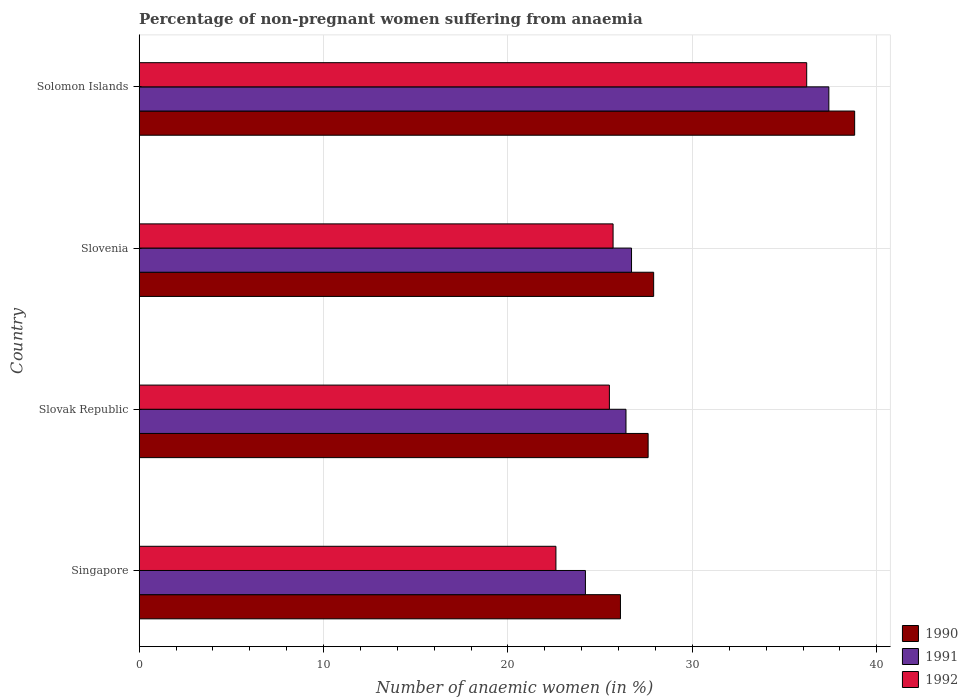How many different coloured bars are there?
Provide a succinct answer. 3. How many groups of bars are there?
Provide a succinct answer. 4. How many bars are there on the 2nd tick from the bottom?
Your answer should be compact. 3. What is the label of the 1st group of bars from the top?
Your answer should be compact. Solomon Islands. What is the percentage of non-pregnant women suffering from anaemia in 1991 in Singapore?
Ensure brevity in your answer.  24.2. Across all countries, what is the maximum percentage of non-pregnant women suffering from anaemia in 1992?
Provide a succinct answer. 36.2. Across all countries, what is the minimum percentage of non-pregnant women suffering from anaemia in 1991?
Your answer should be very brief. 24.2. In which country was the percentage of non-pregnant women suffering from anaemia in 1992 maximum?
Provide a succinct answer. Solomon Islands. In which country was the percentage of non-pregnant women suffering from anaemia in 1992 minimum?
Make the answer very short. Singapore. What is the total percentage of non-pregnant women suffering from anaemia in 1992 in the graph?
Keep it short and to the point. 110. What is the difference between the percentage of non-pregnant women suffering from anaemia in 1990 in Slovenia and that in Solomon Islands?
Give a very brief answer. -10.9. What is the difference between the percentage of non-pregnant women suffering from anaemia in 1990 in Solomon Islands and the percentage of non-pregnant women suffering from anaemia in 1992 in Slovenia?
Keep it short and to the point. 13.1. What is the average percentage of non-pregnant women suffering from anaemia in 1990 per country?
Give a very brief answer. 30.1. What is the difference between the percentage of non-pregnant women suffering from anaemia in 1992 and percentage of non-pregnant women suffering from anaemia in 1991 in Solomon Islands?
Make the answer very short. -1.2. In how many countries, is the percentage of non-pregnant women suffering from anaemia in 1990 greater than 28 %?
Your answer should be compact. 1. What is the ratio of the percentage of non-pregnant women suffering from anaemia in 1990 in Slovak Republic to that in Slovenia?
Provide a succinct answer. 0.99. What is the difference between the highest and the second highest percentage of non-pregnant women suffering from anaemia in 1990?
Make the answer very short. 10.9. What is the difference between the highest and the lowest percentage of non-pregnant women suffering from anaemia in 1991?
Provide a short and direct response. 13.2. Is the sum of the percentage of non-pregnant women suffering from anaemia in 1991 in Singapore and Slovenia greater than the maximum percentage of non-pregnant women suffering from anaemia in 1992 across all countries?
Offer a very short reply. Yes. What does the 1st bar from the bottom in Singapore represents?
Your answer should be very brief. 1990. How many bars are there?
Give a very brief answer. 12. Are all the bars in the graph horizontal?
Your response must be concise. Yes. How many countries are there in the graph?
Your response must be concise. 4. What is the title of the graph?
Ensure brevity in your answer.  Percentage of non-pregnant women suffering from anaemia. What is the label or title of the X-axis?
Provide a succinct answer. Number of anaemic women (in %). What is the label or title of the Y-axis?
Provide a succinct answer. Country. What is the Number of anaemic women (in %) in 1990 in Singapore?
Ensure brevity in your answer.  26.1. What is the Number of anaemic women (in %) of 1991 in Singapore?
Your response must be concise. 24.2. What is the Number of anaemic women (in %) in 1992 in Singapore?
Make the answer very short. 22.6. What is the Number of anaemic women (in %) in 1990 in Slovak Republic?
Your response must be concise. 27.6. What is the Number of anaemic women (in %) in 1991 in Slovak Republic?
Make the answer very short. 26.4. What is the Number of anaemic women (in %) in 1992 in Slovak Republic?
Make the answer very short. 25.5. What is the Number of anaemic women (in %) in 1990 in Slovenia?
Ensure brevity in your answer.  27.9. What is the Number of anaemic women (in %) in 1991 in Slovenia?
Offer a very short reply. 26.7. What is the Number of anaemic women (in %) in 1992 in Slovenia?
Your answer should be compact. 25.7. What is the Number of anaemic women (in %) of 1990 in Solomon Islands?
Offer a terse response. 38.8. What is the Number of anaemic women (in %) of 1991 in Solomon Islands?
Keep it short and to the point. 37.4. What is the Number of anaemic women (in %) in 1992 in Solomon Islands?
Provide a short and direct response. 36.2. Across all countries, what is the maximum Number of anaemic women (in %) in 1990?
Provide a succinct answer. 38.8. Across all countries, what is the maximum Number of anaemic women (in %) in 1991?
Make the answer very short. 37.4. Across all countries, what is the maximum Number of anaemic women (in %) in 1992?
Your response must be concise. 36.2. Across all countries, what is the minimum Number of anaemic women (in %) of 1990?
Provide a succinct answer. 26.1. Across all countries, what is the minimum Number of anaemic women (in %) of 1991?
Provide a succinct answer. 24.2. Across all countries, what is the minimum Number of anaemic women (in %) of 1992?
Give a very brief answer. 22.6. What is the total Number of anaemic women (in %) of 1990 in the graph?
Make the answer very short. 120.4. What is the total Number of anaemic women (in %) of 1991 in the graph?
Make the answer very short. 114.7. What is the total Number of anaemic women (in %) of 1992 in the graph?
Offer a terse response. 110. What is the difference between the Number of anaemic women (in %) in 1990 in Singapore and that in Slovak Republic?
Give a very brief answer. -1.5. What is the difference between the Number of anaemic women (in %) of 1990 in Singapore and that in Slovenia?
Provide a short and direct response. -1.8. What is the difference between the Number of anaemic women (in %) of 1991 in Singapore and that in Slovenia?
Give a very brief answer. -2.5. What is the difference between the Number of anaemic women (in %) of 1991 in Singapore and that in Solomon Islands?
Make the answer very short. -13.2. What is the difference between the Number of anaemic women (in %) in 1990 in Slovak Republic and that in Slovenia?
Your response must be concise. -0.3. What is the difference between the Number of anaemic women (in %) in 1992 in Slovak Republic and that in Slovenia?
Offer a very short reply. -0.2. What is the difference between the Number of anaemic women (in %) in 1990 in Slovak Republic and that in Solomon Islands?
Your response must be concise. -11.2. What is the difference between the Number of anaemic women (in %) in 1991 in Slovak Republic and that in Solomon Islands?
Offer a very short reply. -11. What is the difference between the Number of anaemic women (in %) in 1992 in Slovak Republic and that in Solomon Islands?
Keep it short and to the point. -10.7. What is the difference between the Number of anaemic women (in %) of 1990 in Singapore and the Number of anaemic women (in %) of 1991 in Slovak Republic?
Keep it short and to the point. -0.3. What is the difference between the Number of anaemic women (in %) of 1990 in Singapore and the Number of anaemic women (in %) of 1992 in Solomon Islands?
Provide a short and direct response. -10.1. What is the difference between the Number of anaemic women (in %) in 1991 in Singapore and the Number of anaemic women (in %) in 1992 in Solomon Islands?
Give a very brief answer. -12. What is the difference between the Number of anaemic women (in %) in 1990 in Slovak Republic and the Number of anaemic women (in %) in 1991 in Slovenia?
Offer a very short reply. 0.9. What is the difference between the Number of anaemic women (in %) in 1990 in Slovak Republic and the Number of anaemic women (in %) in 1992 in Solomon Islands?
Give a very brief answer. -8.6. What is the difference between the Number of anaemic women (in %) of 1991 in Slovak Republic and the Number of anaemic women (in %) of 1992 in Solomon Islands?
Offer a terse response. -9.8. What is the difference between the Number of anaemic women (in %) in 1990 in Slovenia and the Number of anaemic women (in %) in 1991 in Solomon Islands?
Offer a very short reply. -9.5. What is the difference between the Number of anaemic women (in %) in 1991 in Slovenia and the Number of anaemic women (in %) in 1992 in Solomon Islands?
Offer a terse response. -9.5. What is the average Number of anaemic women (in %) in 1990 per country?
Make the answer very short. 30.1. What is the average Number of anaemic women (in %) in 1991 per country?
Ensure brevity in your answer.  28.68. What is the difference between the Number of anaemic women (in %) in 1990 and Number of anaemic women (in %) in 1991 in Singapore?
Give a very brief answer. 1.9. What is the difference between the Number of anaemic women (in %) in 1990 and Number of anaemic women (in %) in 1992 in Singapore?
Your response must be concise. 3.5. What is the difference between the Number of anaemic women (in %) of 1991 and Number of anaemic women (in %) of 1992 in Singapore?
Provide a succinct answer. 1.6. What is the difference between the Number of anaemic women (in %) in 1990 and Number of anaemic women (in %) in 1991 in Slovak Republic?
Give a very brief answer. 1.2. What is the difference between the Number of anaemic women (in %) of 1990 and Number of anaemic women (in %) of 1991 in Slovenia?
Ensure brevity in your answer.  1.2. What is the difference between the Number of anaemic women (in %) in 1990 and Number of anaemic women (in %) in 1991 in Solomon Islands?
Offer a terse response. 1.4. What is the difference between the Number of anaemic women (in %) in 1990 and Number of anaemic women (in %) in 1992 in Solomon Islands?
Make the answer very short. 2.6. What is the ratio of the Number of anaemic women (in %) of 1990 in Singapore to that in Slovak Republic?
Offer a terse response. 0.95. What is the ratio of the Number of anaemic women (in %) of 1991 in Singapore to that in Slovak Republic?
Keep it short and to the point. 0.92. What is the ratio of the Number of anaemic women (in %) in 1992 in Singapore to that in Slovak Republic?
Offer a terse response. 0.89. What is the ratio of the Number of anaemic women (in %) in 1990 in Singapore to that in Slovenia?
Offer a terse response. 0.94. What is the ratio of the Number of anaemic women (in %) in 1991 in Singapore to that in Slovenia?
Your response must be concise. 0.91. What is the ratio of the Number of anaemic women (in %) in 1992 in Singapore to that in Slovenia?
Your answer should be compact. 0.88. What is the ratio of the Number of anaemic women (in %) in 1990 in Singapore to that in Solomon Islands?
Your answer should be compact. 0.67. What is the ratio of the Number of anaemic women (in %) in 1991 in Singapore to that in Solomon Islands?
Offer a terse response. 0.65. What is the ratio of the Number of anaemic women (in %) of 1992 in Singapore to that in Solomon Islands?
Keep it short and to the point. 0.62. What is the ratio of the Number of anaemic women (in %) in 1992 in Slovak Republic to that in Slovenia?
Your answer should be very brief. 0.99. What is the ratio of the Number of anaemic women (in %) of 1990 in Slovak Republic to that in Solomon Islands?
Offer a very short reply. 0.71. What is the ratio of the Number of anaemic women (in %) in 1991 in Slovak Republic to that in Solomon Islands?
Keep it short and to the point. 0.71. What is the ratio of the Number of anaemic women (in %) of 1992 in Slovak Republic to that in Solomon Islands?
Offer a very short reply. 0.7. What is the ratio of the Number of anaemic women (in %) of 1990 in Slovenia to that in Solomon Islands?
Make the answer very short. 0.72. What is the ratio of the Number of anaemic women (in %) in 1991 in Slovenia to that in Solomon Islands?
Offer a very short reply. 0.71. What is the ratio of the Number of anaemic women (in %) of 1992 in Slovenia to that in Solomon Islands?
Make the answer very short. 0.71. What is the difference between the highest and the second highest Number of anaemic women (in %) in 1990?
Offer a terse response. 10.9. What is the difference between the highest and the second highest Number of anaemic women (in %) of 1991?
Make the answer very short. 10.7. What is the difference between the highest and the second highest Number of anaemic women (in %) in 1992?
Make the answer very short. 10.5. What is the difference between the highest and the lowest Number of anaemic women (in %) in 1992?
Provide a short and direct response. 13.6. 